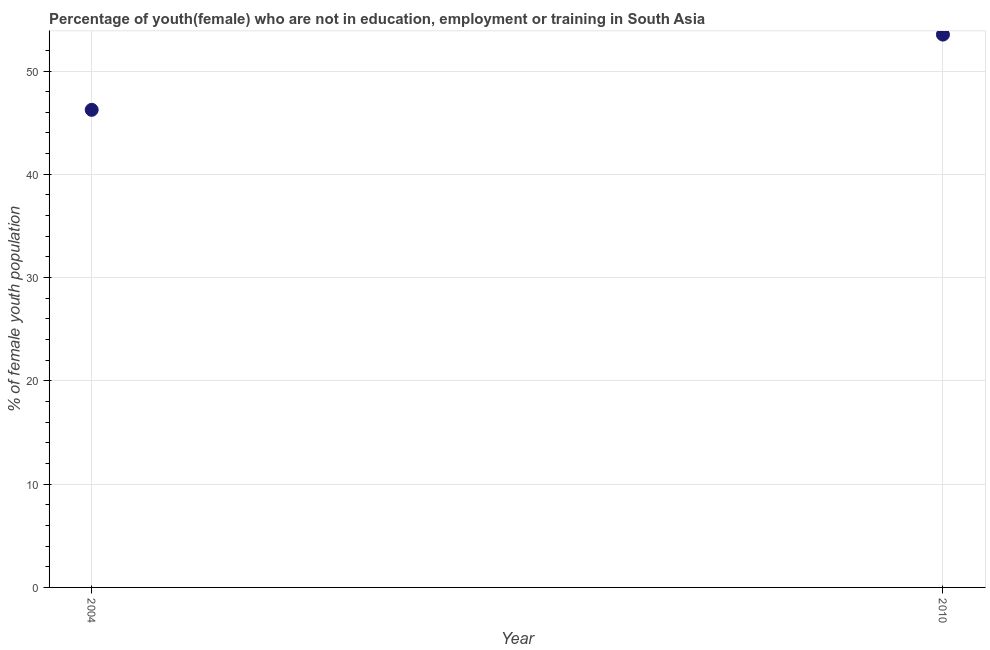What is the unemployed female youth population in 2010?
Your answer should be compact. 53.53. Across all years, what is the maximum unemployed female youth population?
Make the answer very short. 53.53. Across all years, what is the minimum unemployed female youth population?
Keep it short and to the point. 46.24. What is the sum of the unemployed female youth population?
Give a very brief answer. 99.77. What is the difference between the unemployed female youth population in 2004 and 2010?
Keep it short and to the point. -7.29. What is the average unemployed female youth population per year?
Ensure brevity in your answer.  49.88. What is the median unemployed female youth population?
Your response must be concise. 49.88. In how many years, is the unemployed female youth population greater than 46 %?
Provide a short and direct response. 2. Do a majority of the years between 2004 and 2010 (inclusive) have unemployed female youth population greater than 24 %?
Provide a succinct answer. Yes. What is the ratio of the unemployed female youth population in 2004 to that in 2010?
Offer a very short reply. 0.86. In how many years, is the unemployed female youth population greater than the average unemployed female youth population taken over all years?
Provide a succinct answer. 1. What is the title of the graph?
Your answer should be very brief. Percentage of youth(female) who are not in education, employment or training in South Asia. What is the label or title of the X-axis?
Provide a short and direct response. Year. What is the label or title of the Y-axis?
Your response must be concise. % of female youth population. What is the % of female youth population in 2004?
Keep it short and to the point. 46.24. What is the % of female youth population in 2010?
Provide a succinct answer. 53.53. What is the difference between the % of female youth population in 2004 and 2010?
Offer a terse response. -7.29. What is the ratio of the % of female youth population in 2004 to that in 2010?
Your response must be concise. 0.86. 